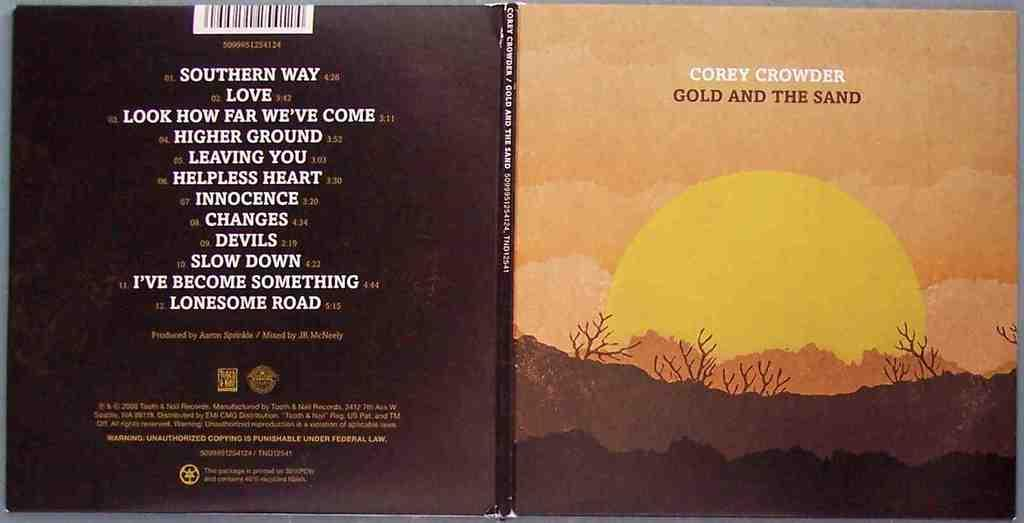<image>
Summarize the visual content of the image. Corey Crowder's album includes the song Love and the song Changes. 